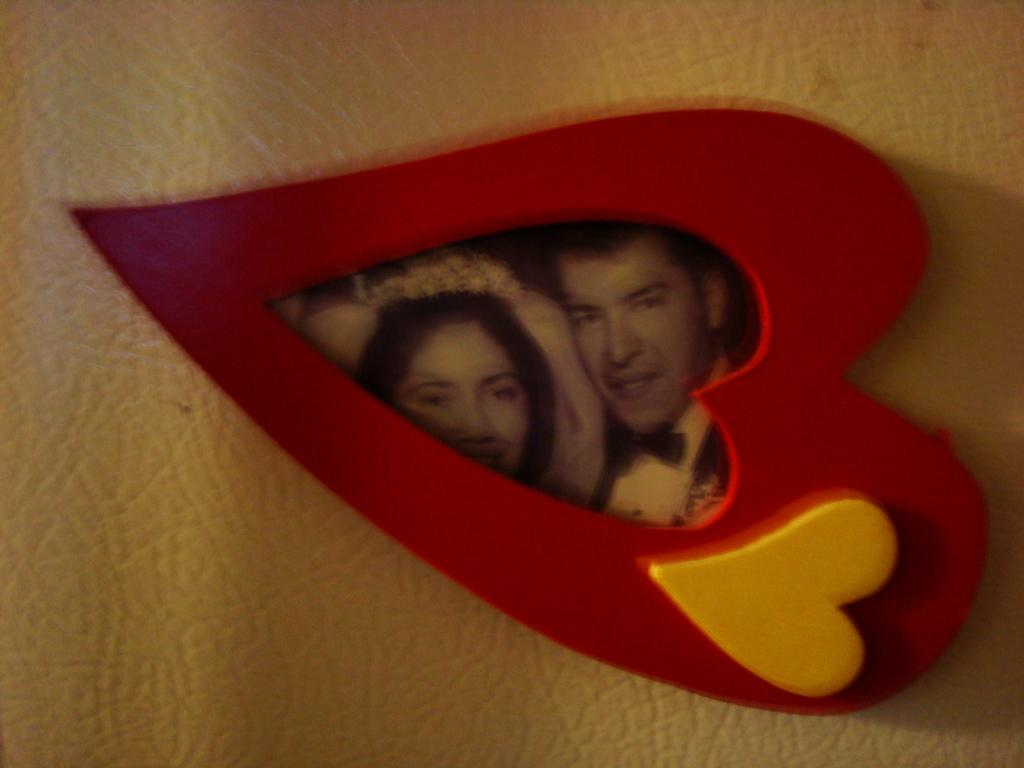What object can be seen in the image that typically holds a photograph? There is a photo frame in the image. How many people are visible in the photo frame? The photo frame contains two people. What type of yarn is being used to create the rabbit in the image? There is no yarn or rabbit present in the image; it only features a photo frame with two people. 